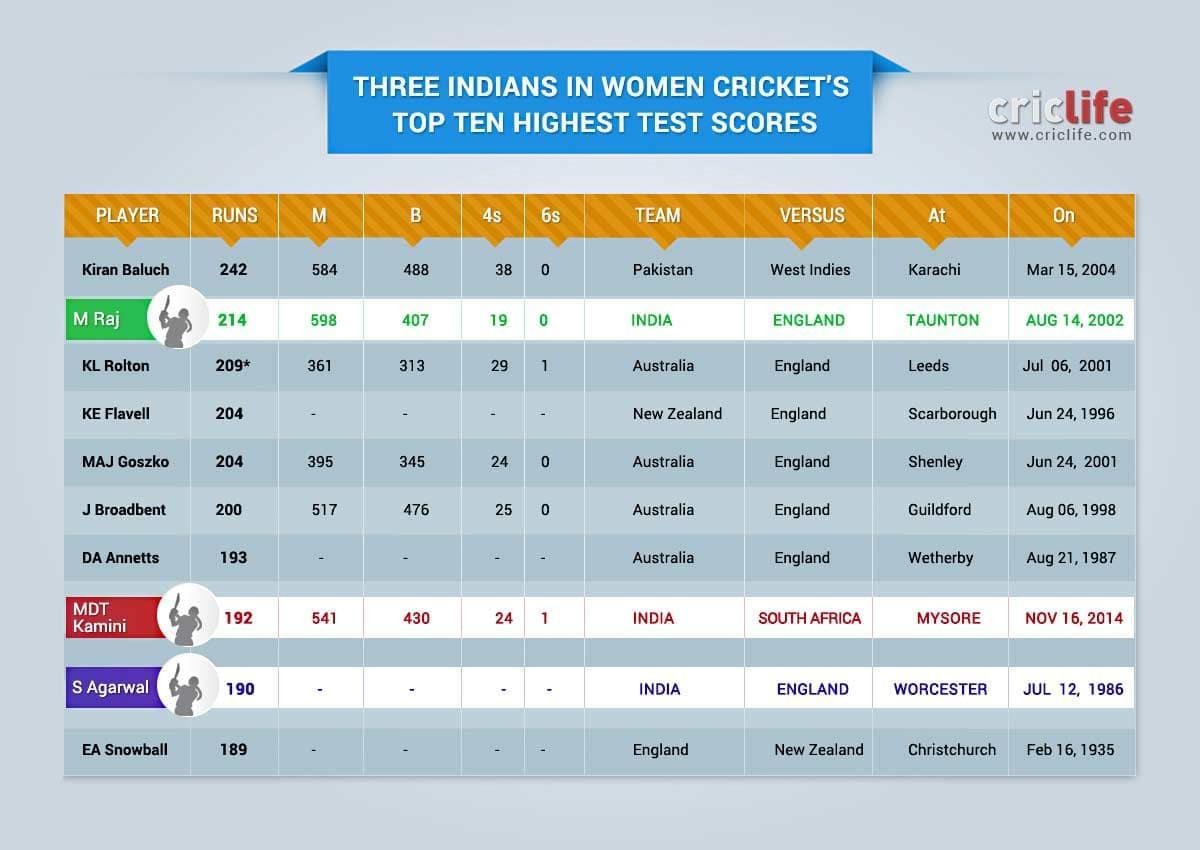What is the number of runs scored by MDT Kamini in India-South Africa test match on Nov 16, 2014?
Answer the question with a short phrase. 192 How many fours were scored by MAJ Goszko in Australia-England test match on June 24, 2001? 24 Which country did Kiran Baluch play for? Pakistan Where was the Australia-England women's test match conducted on July 06, 2001? Leeds Where was the India-Australia women's test match conducted on November 16, 2014? MYSORE What is the highest test score of MAJ Goszko? 204 How many sixes were scored by MDT Kamini  in India-South Africa test match on Nov 16, 2014? 1 How many fours were scored by M Raj in India-England test match on Aug 14, 2002? 19 Which country did KE Flavell play for? New Zealand What is the highest test score of KL Rolton? 209* 